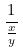Convert formula to latex. <formula><loc_0><loc_0><loc_500><loc_500>\frac { 1 } { \frac { x } { y } }</formula> 